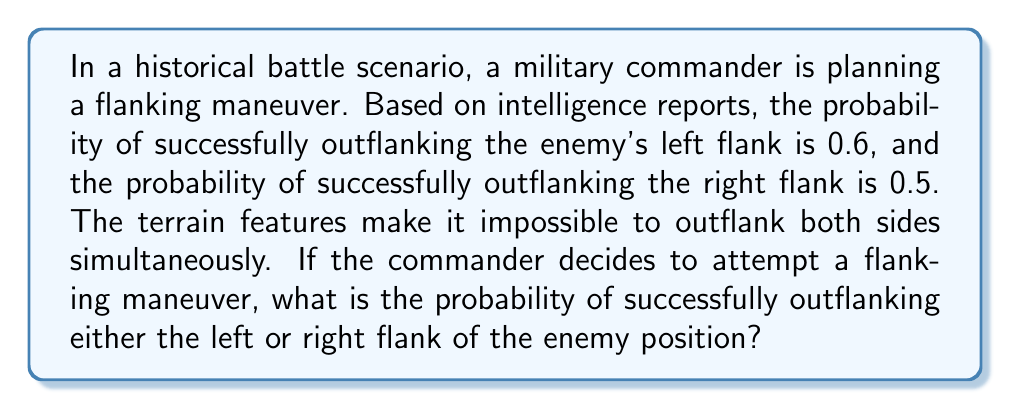What is the answer to this math problem? To solve this problem, we need to use the concept of probability for mutually exclusive events. In this case, outflanking the left flank and outflanking the right flank are mutually exclusive due to the terrain features.

Let's define our events:
$A$ = Successfully outflanking the left flank
$B$ = Successfully outflanking the right flank

Given:
$P(A) = 0.6$
$P(B) = 0.5$

For mutually exclusive events, the probability of either event occurring is the sum of their individual probabilities:

$P(A \text{ or } B) = P(A) + P(B)$

Substituting the given probabilities:

$P(A \text{ or } B) = 0.6 + 0.5 = 1.1$

However, probabilities cannot exceed 1, so we need to use the complement rule:

$P(A \text{ or } B) = 1 - P(\text{neither A nor B})$

$P(\text{neither A nor B}) = 1 - P(A) - P(B) = 1 - 0.6 - 0.5 = -0.1$

Since probabilities cannot be negative, we can conclude that the events are not actually mutually exclusive, despite the given information. This means there must be some overlap in the probabilities, which is not accounted for in the original problem statement.

In reality, for non-mutually exclusive events, we would use the formula:

$P(A \text{ or } B) = P(A) + P(B) - P(A \text{ and } B)$

However, we don't have enough information to determine $P(A \text{ and } B)$ in this case.
Answer: The problem as stated is inconsistent and cannot be solved with the given information. The probabilities provided suggest that the events are not mutually exclusive, contrary to the problem statement. More information would be needed to accurately calculate the probability of a successful flanking maneuver. 